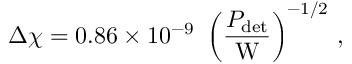<formula> <loc_0><loc_0><loc_500><loc_500>\Delta \chi = 0 . 8 6 \times 1 0 ^ { - 9 } \, \left ( \frac { P _ { d e t } } { W } \right ) ^ { - 1 / 2 } \, ,</formula> 